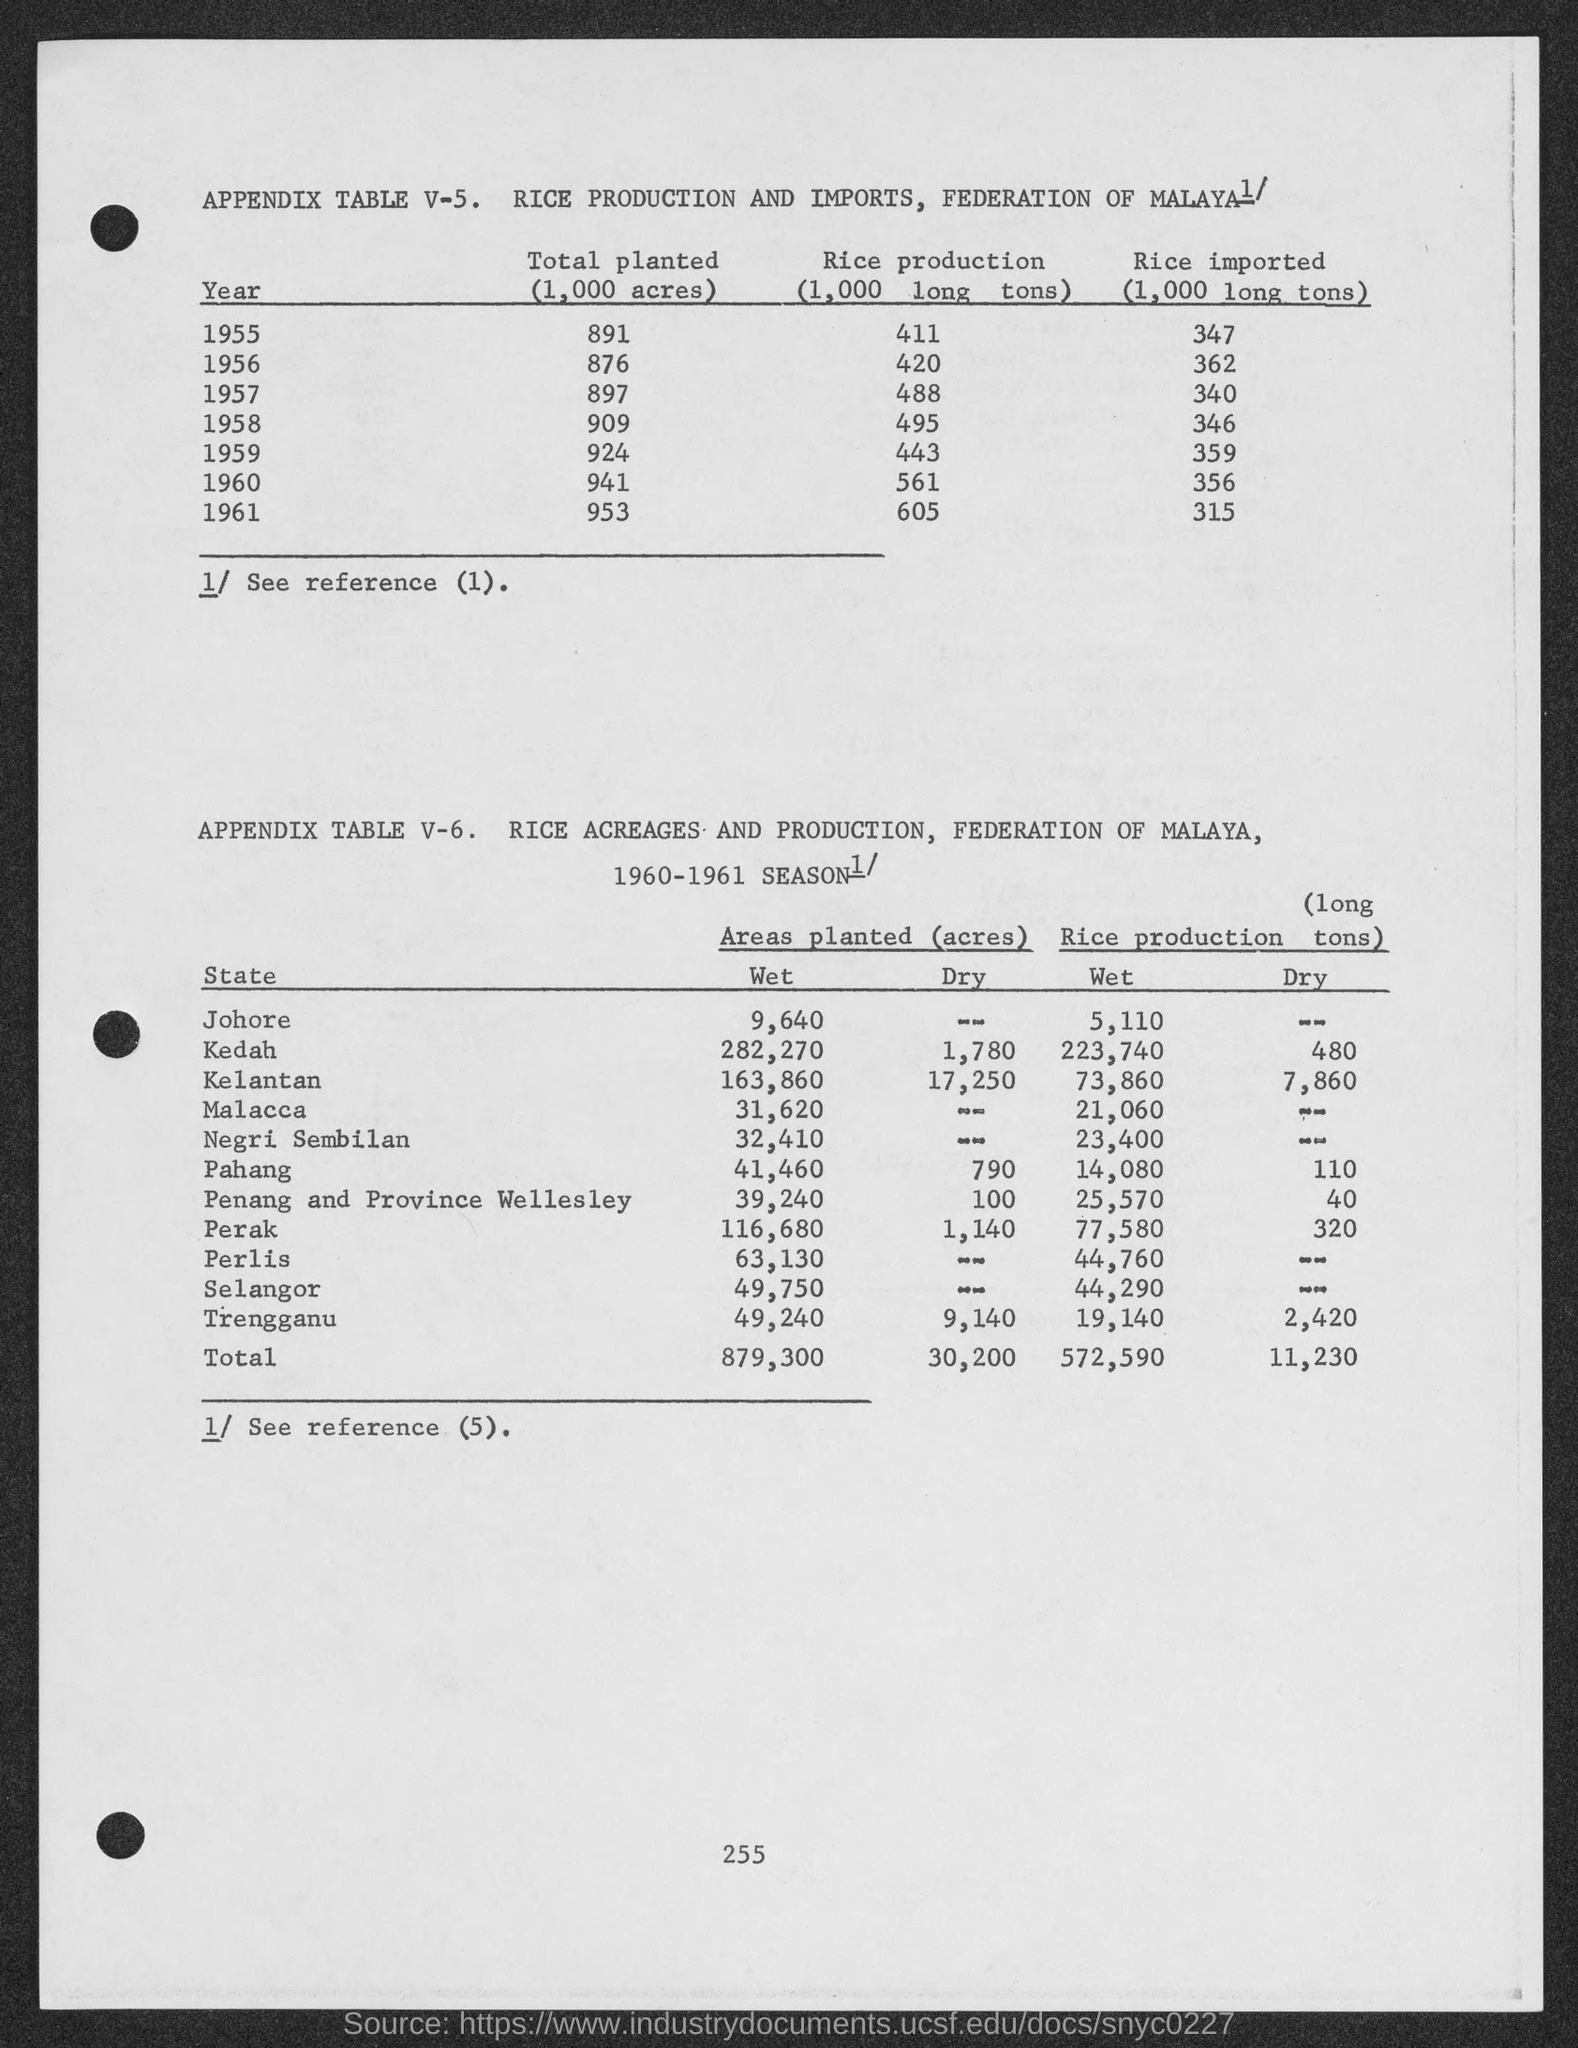What is the amount of rice production in the year 1955?
Provide a short and direct response. 411. What is the amount of rice production in the year 1956?
Your response must be concise. 420. What is the amount of rice production in the year 1957 ?
Your response must be concise. 488. What is the amount of rice imported in the year 1955 ?
Offer a very short reply. 347. What is the amount of rice imported in the year 1956 ?
Offer a very short reply. 362. What is the amount of total planted in the year 1955 ?
Offer a very short reply. 891. What is the amount of total planted in the year 1956 ?
Give a very brief answer. 876. What is the amount of rice imported in the year 1959 ?
Provide a short and direct response. 359. What is the total wet rice production as mentioned in the given table ?
Keep it short and to the point. 572,590. What is the amount of total dry rice production as mentioned in the given table ?
Make the answer very short. 11,230. 